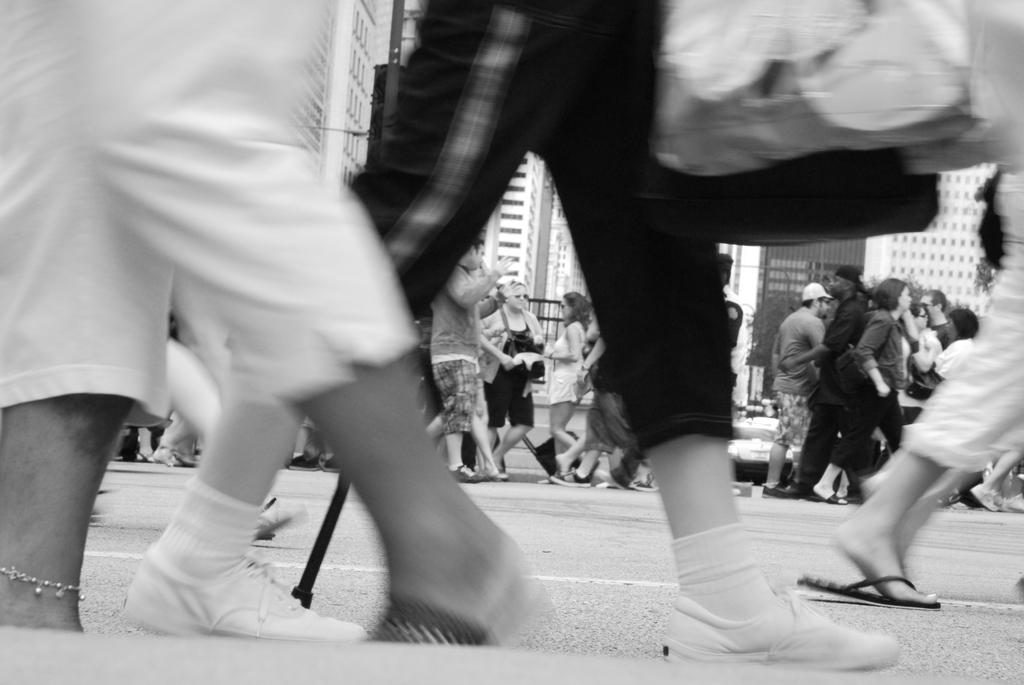What is the color scheme of the image? The image is black and white. What are the people in the image doing? People are walking on a road in the image. What can be seen in the background of the image? There are buildings in the background of the image. What type of van can be seen parked near the buildings in the image? There is no van present in the image; it is a black and white and features people walking on a road with buildings in the background. 